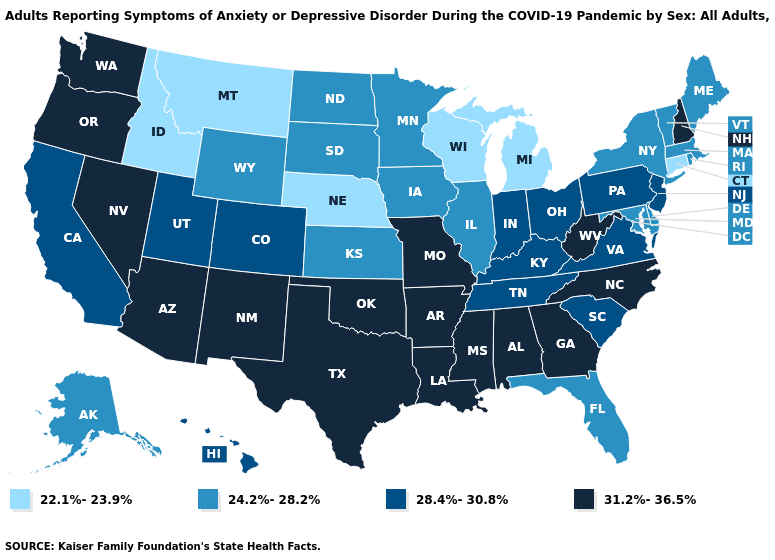What is the lowest value in states that border Louisiana?
Write a very short answer. 31.2%-36.5%. What is the highest value in the South ?
Quick response, please. 31.2%-36.5%. Among the states that border Georgia , which have the lowest value?
Write a very short answer. Florida. Name the states that have a value in the range 24.2%-28.2%?
Short answer required. Alaska, Delaware, Florida, Illinois, Iowa, Kansas, Maine, Maryland, Massachusetts, Minnesota, New York, North Dakota, Rhode Island, South Dakota, Vermont, Wyoming. Is the legend a continuous bar?
Concise answer only. No. What is the highest value in states that border Minnesota?
Give a very brief answer. 24.2%-28.2%. Does Iowa have a lower value than Georgia?
Short answer required. Yes. What is the highest value in the USA?
Quick response, please. 31.2%-36.5%. What is the lowest value in states that border Wyoming?
Keep it brief. 22.1%-23.9%. Among the states that border Vermont , which have the lowest value?
Give a very brief answer. Massachusetts, New York. What is the highest value in the USA?
Answer briefly. 31.2%-36.5%. Which states have the lowest value in the Northeast?
Keep it brief. Connecticut. Name the states that have a value in the range 31.2%-36.5%?
Quick response, please. Alabama, Arizona, Arkansas, Georgia, Louisiana, Mississippi, Missouri, Nevada, New Hampshire, New Mexico, North Carolina, Oklahoma, Oregon, Texas, Washington, West Virginia. Name the states that have a value in the range 22.1%-23.9%?
Short answer required. Connecticut, Idaho, Michigan, Montana, Nebraska, Wisconsin. 